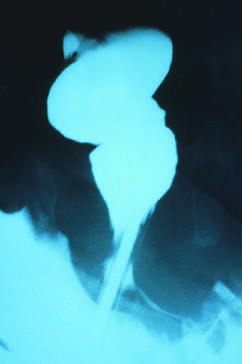were ganglion cells absent in the rectum, but presented in the sigmoid colon?
Answer the question using a single word or phrase. Yes 